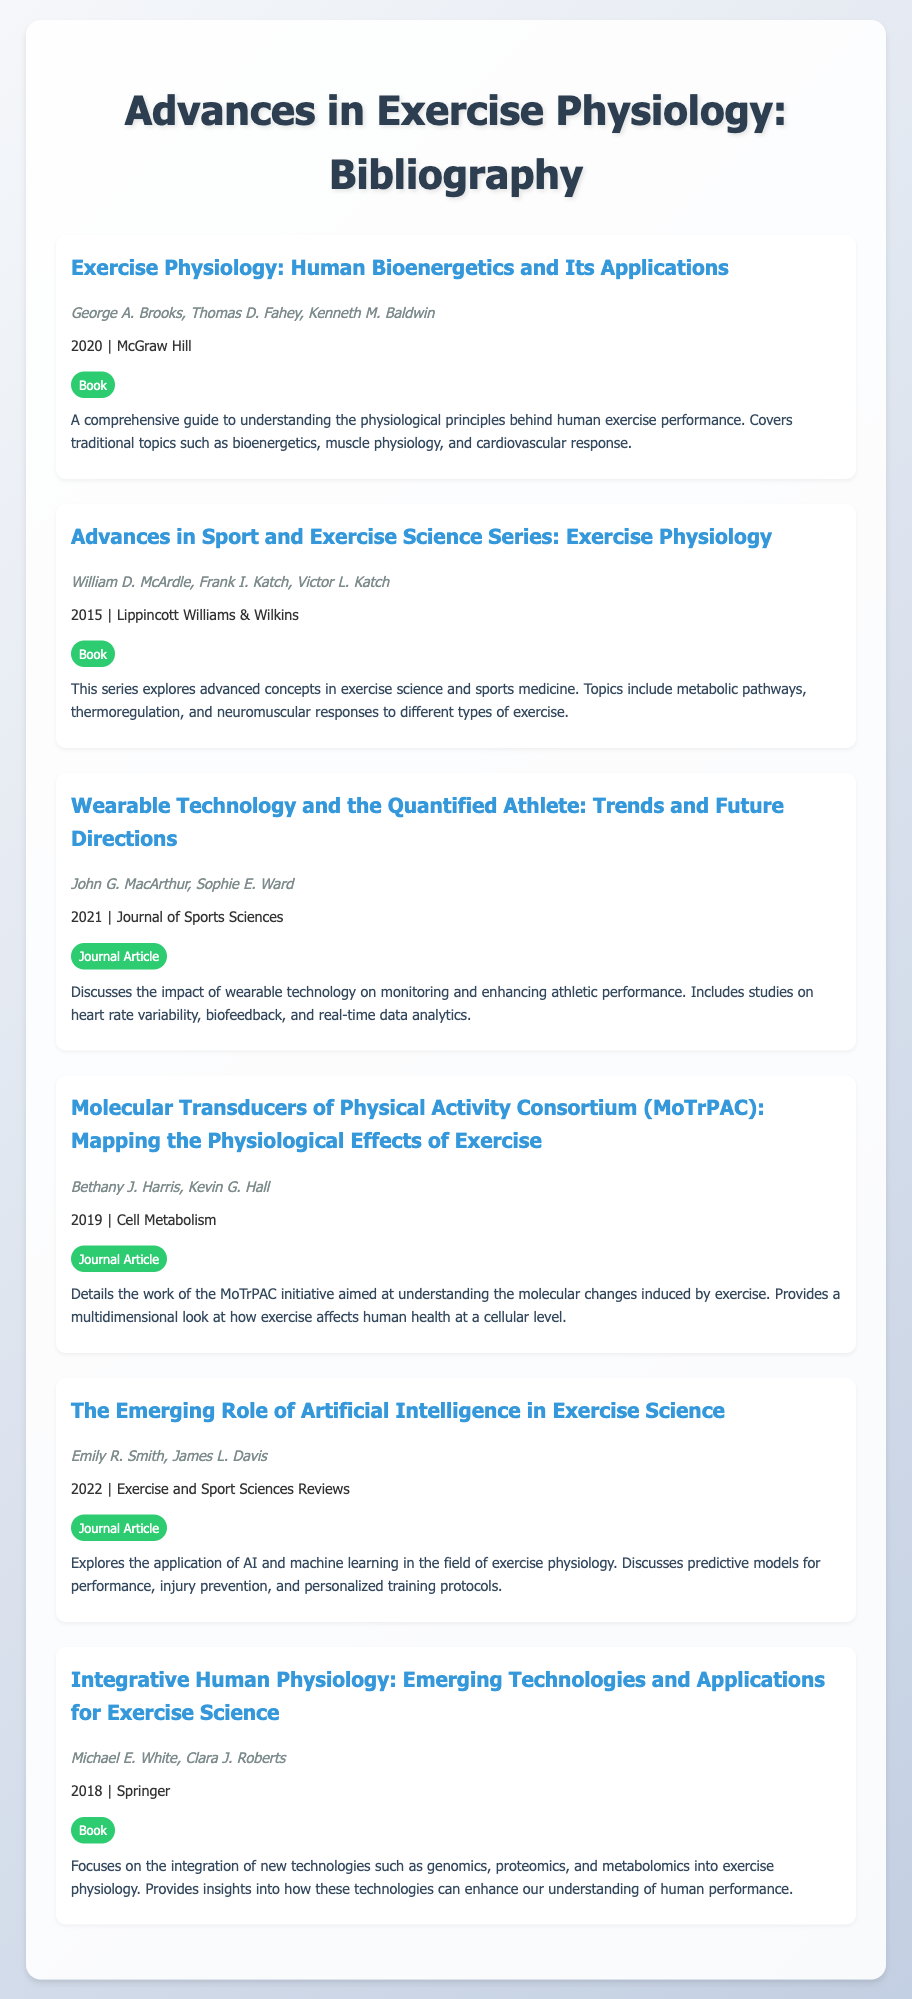What is the title of the first book listed? The title of the first book listed is the first entry of the bibliography.
Answer: Exercise Physiology: Human Bioenergetics and Its Applications Who are the authors of the second book? The authors of the second book are mentioned below the title in the second entry.
Answer: William D. McArdle, Frank I. Katch, Victor L. Katch What year was the journal article about wearable technology published? The year of publication for the journal article on wearable technology is provided alongside the title in the third entry.
Answer: 2021 What is the resource type of the article titled "The Emerging Role of Artificial Intelligence in Exercise Science"? The resource type is indicated by a label in the same entry as the article title.
Answer: Journal Article How many journal articles are included in the bibliography? The total number of entries classified as journal articles can be counted from the document.
Answer: 3 Which publisher released the book "Integrative Human Physiology"? The publisher of the book is provided in the publication details of the entry.
Answer: Springer What is the common theme among the topics covered in this bibliography? The common theme can be inferred from the titles and descriptions provided in the entries.
Answer: Exercise Physiology What recent technological advancement is discussed in the entry by Emily R. Smith and James L. Davis? The specific advancement is outlined in the title of the journal article.
Answer: Artificial Intelligence 